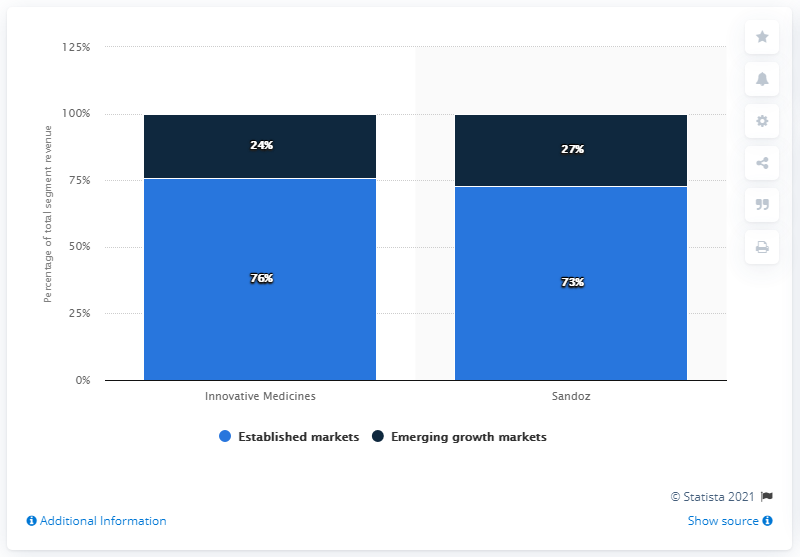Draw attention to some important aspects in this diagram. In 2020, the division of Novartis AG that generated the largest portion of its revenue from established markets was Innovative Medicines, which accounted for 76% of its revenue in that category. In the chart, one bar represents Innovative Medicines, and another bar represents Sandoz. The value of established markets, when compared to the value of emerging growth markets, results in a difference of 98. 